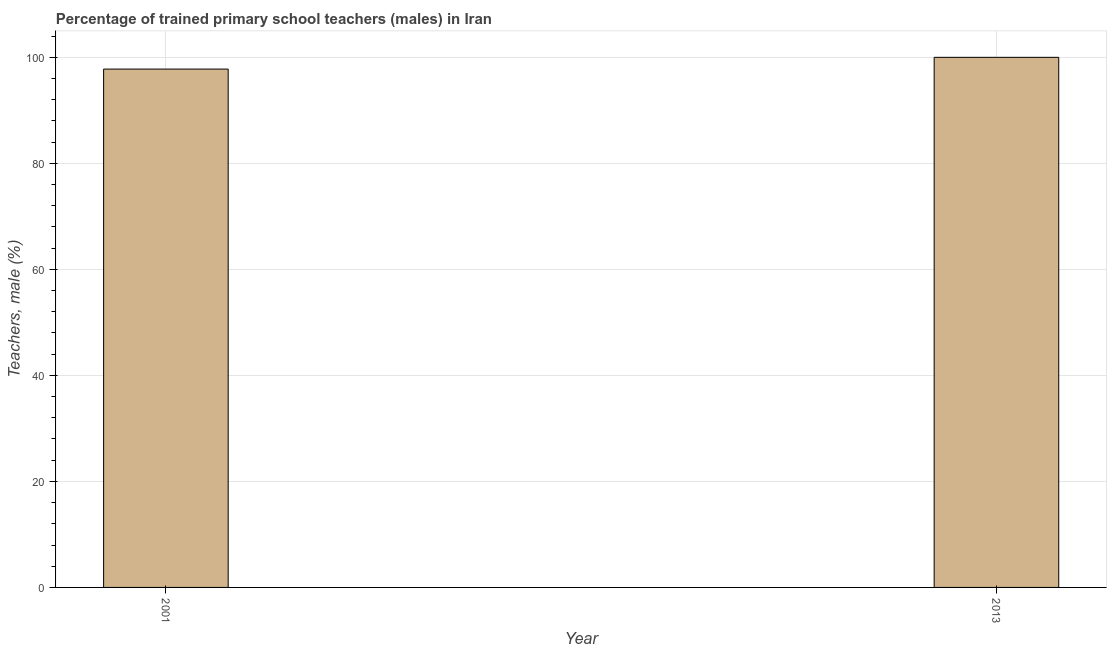Does the graph contain any zero values?
Your answer should be compact. No. Does the graph contain grids?
Your answer should be compact. Yes. What is the title of the graph?
Provide a succinct answer. Percentage of trained primary school teachers (males) in Iran. What is the label or title of the Y-axis?
Your response must be concise. Teachers, male (%). What is the percentage of trained male teachers in 2013?
Your response must be concise. 100. Across all years, what is the maximum percentage of trained male teachers?
Offer a very short reply. 100. Across all years, what is the minimum percentage of trained male teachers?
Your response must be concise. 97.78. In which year was the percentage of trained male teachers maximum?
Ensure brevity in your answer.  2013. What is the sum of the percentage of trained male teachers?
Offer a very short reply. 197.78. What is the difference between the percentage of trained male teachers in 2001 and 2013?
Offer a very short reply. -2.22. What is the average percentage of trained male teachers per year?
Ensure brevity in your answer.  98.89. What is the median percentage of trained male teachers?
Provide a short and direct response. 98.89. In how many years, is the percentage of trained male teachers greater than 4 %?
Offer a terse response. 2. What is the ratio of the percentage of trained male teachers in 2001 to that in 2013?
Keep it short and to the point. 0.98. In how many years, is the percentage of trained male teachers greater than the average percentage of trained male teachers taken over all years?
Ensure brevity in your answer.  1. How many bars are there?
Make the answer very short. 2. Are all the bars in the graph horizontal?
Keep it short and to the point. No. How many years are there in the graph?
Offer a terse response. 2. What is the Teachers, male (%) in 2001?
Your answer should be compact. 97.78. What is the Teachers, male (%) in 2013?
Provide a succinct answer. 100. What is the difference between the Teachers, male (%) in 2001 and 2013?
Offer a terse response. -2.22. 